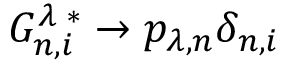Convert formula to latex. <formula><loc_0><loc_0><loc_500><loc_500>G _ { n , i } ^ { \lambda \, * } \to p _ { \lambda , n } \delta _ { n , i }</formula> 